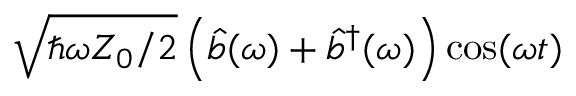<formula> <loc_0><loc_0><loc_500><loc_500>\sqrt { \hbar { \omega } Z _ { 0 } / 2 } \left ( \hat { b } ( \omega ) + \hat { b } ^ { \dagger } ( \omega ) \right ) \cos ( \omega t )</formula> 